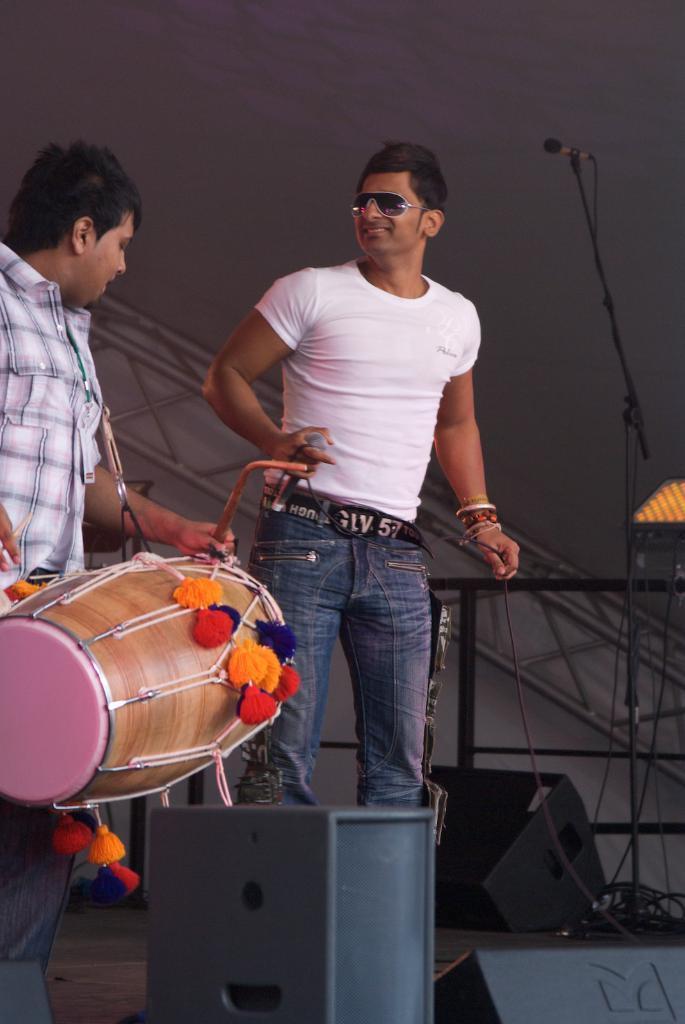Describe this image in one or two sentences. There are two persons in the stage, one person is wearing white t shirt and blue jeans, he is holding mike in one hand and wire in another hand. Towards the left there is another men, he is wearing a check shirt and blue jeans and he is playing drums. To the right side there is a mike and speakers. 